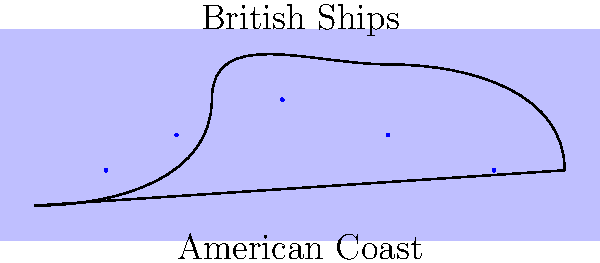Based on the coastal map showing British ship positions during the War of 1812, which naval blockade strategy is most likely being employed by the British fleet? To determine the naval blockade strategy being employed by the British fleet during the War of 1812, let's analyze the map and consider historical context:

1. Ship positioning: The British ships are spread out along the American coastline, maintaining a relatively even distribution.

2. Distance from shore: The ships are positioned close to the coast, but not directly on it, allowing for maneuverability.

3. Coverage: The fleet appears to be covering a significant portion of the coastline, rather than concentrating on a single port or area.

4. Historical context: During the War of 1812, the British Navy implemented a strategy known as the "distant blockade" or "loose blockade."

5. Distant blockade characteristics:
   a. Ships maintain a presence along a stretch of coastline.
   b. Vessels are positioned to intercept enemy ships entering or leaving ports.
   c. The strategy allows for flexibility in responding to American naval movements.
   d. It aims to disrupt American maritime trade and prevent the US Navy from effectively operating.

6. Contrast with close blockade: A close blockade would involve ships stationed directly outside specific ports, which is not seen in this map.

Given the spread of British ships along the coast and their positioning relative to the shoreline, the map clearly depicts the implementation of a distant or loose blockade strategy, which was the primary naval tactic employed by the British during the War of 1812.
Answer: Distant blockade 